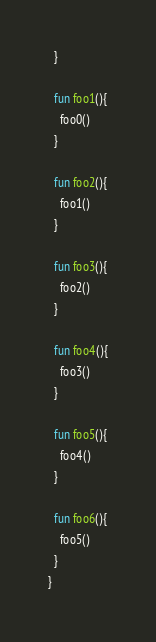Convert code to text. <code><loc_0><loc_0><loc_500><loc_500><_Kotlin_>  }

  fun foo1(){
    foo0()
  }

  fun foo2(){
    foo1()
  }

  fun foo3(){
    foo2()
  }

  fun foo4(){
    foo3()
  }

  fun foo5(){
    foo4()
  }

  fun foo6(){
    foo5()
  }
}</code> 